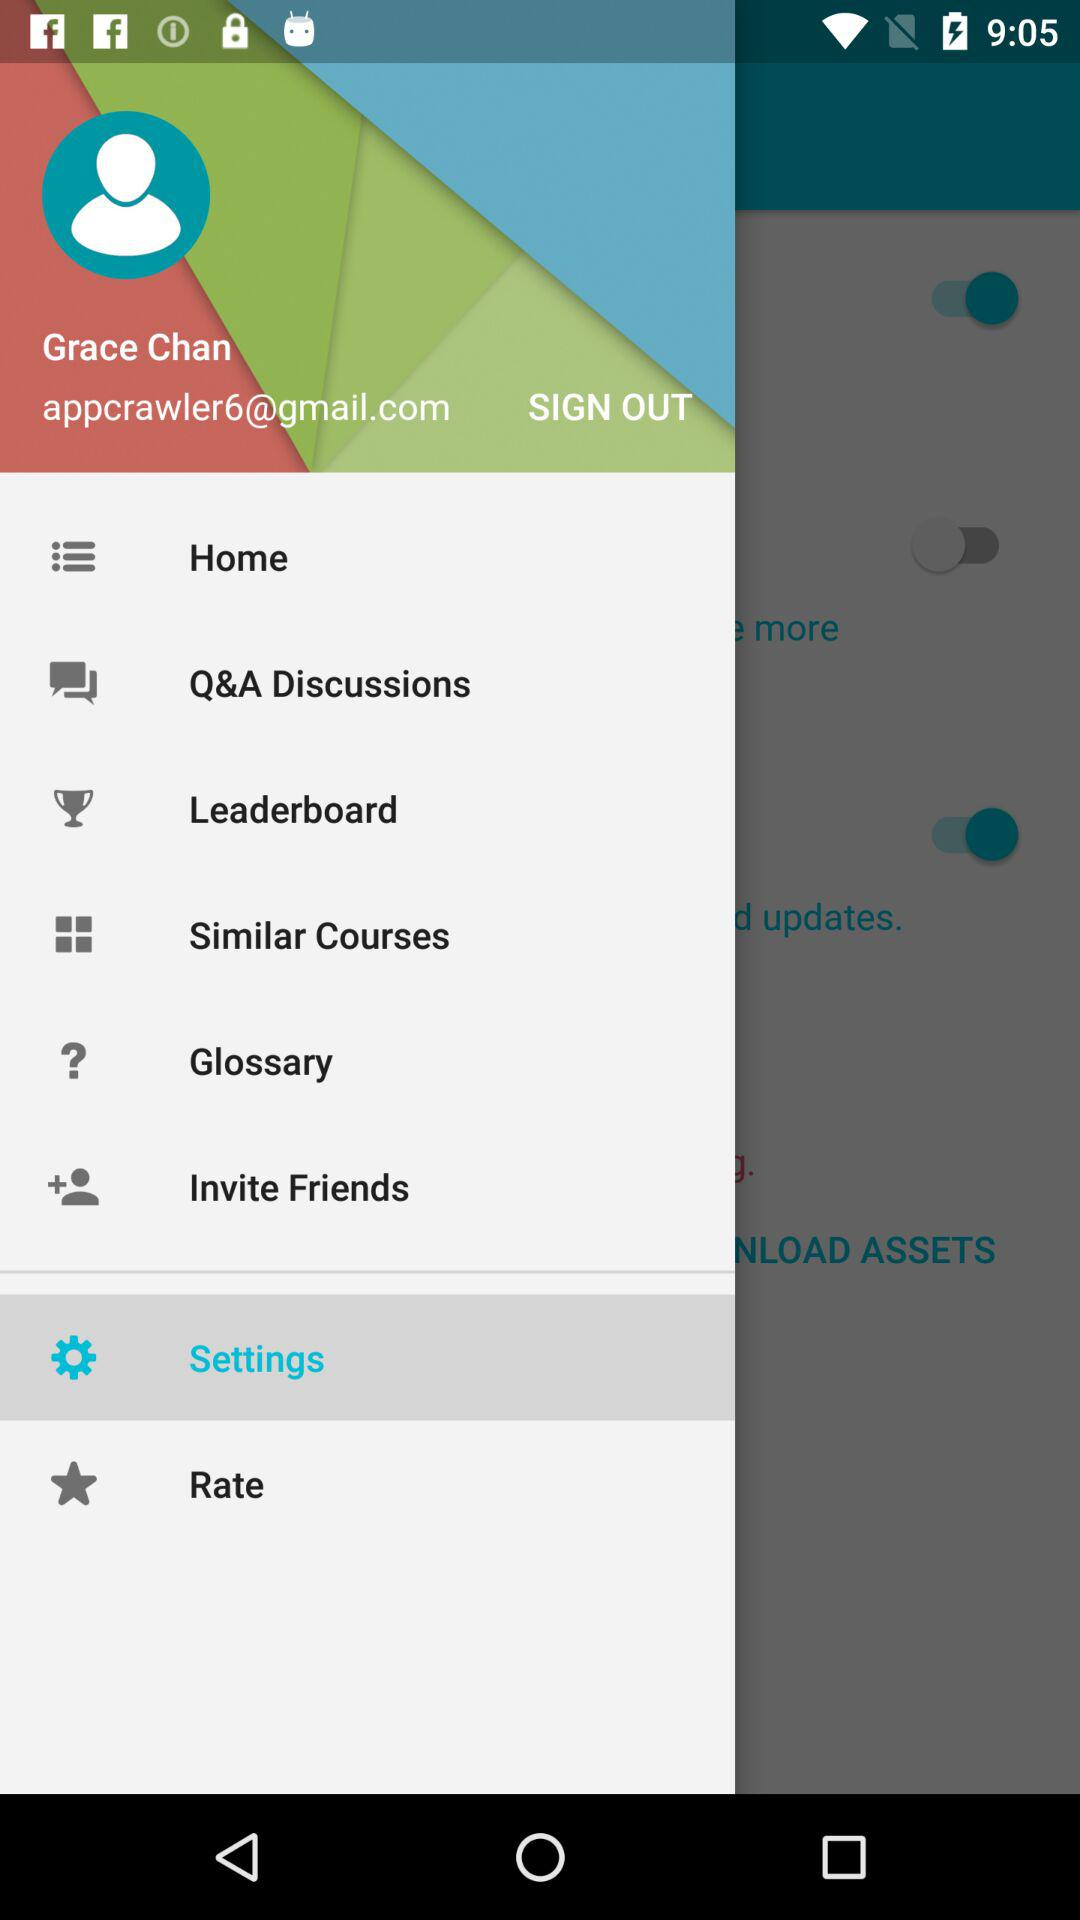What is the username? The username is Grace Chan. 